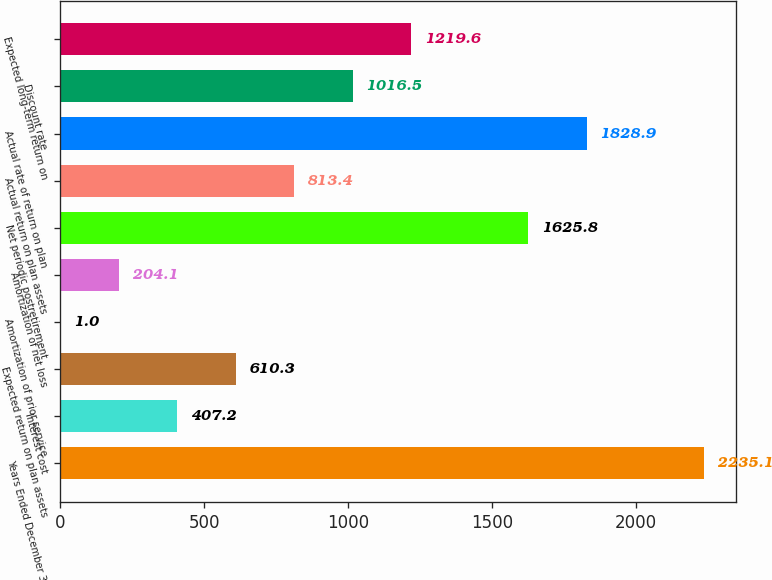<chart> <loc_0><loc_0><loc_500><loc_500><bar_chart><fcel>Years Ended December 31<fcel>Interest cost<fcel>Expected return on plan assets<fcel>Amortization of prior service<fcel>Amortization of net loss<fcel>Net periodic postretirement<fcel>Actual return on plan assets<fcel>Actual rate of return on plan<fcel>Discount rate<fcel>Expected long-term return on<nl><fcel>2235.1<fcel>407.2<fcel>610.3<fcel>1<fcel>204.1<fcel>1625.8<fcel>813.4<fcel>1828.9<fcel>1016.5<fcel>1219.6<nl></chart> 